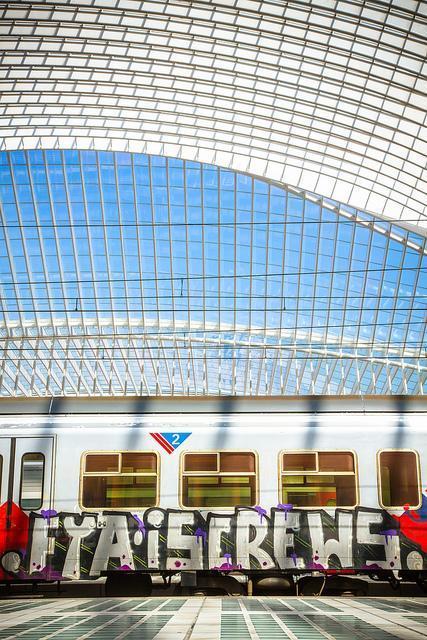How many sheep are there?
Give a very brief answer. 0. 